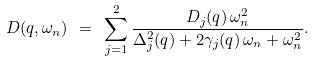Convert formula to latex. <formula><loc_0><loc_0><loc_500><loc_500>D ( q , \omega _ { n } ) \ = \ \sum _ { j = 1 } ^ { 2 } \frac { D _ { j } ( q ) \, \omega _ { n } ^ { 2 } } { \Delta _ { j } ^ { 2 } ( q ) + 2 \gamma _ { j } ( q ) \, \omega _ { n } + \omega _ { n } ^ { 2 } } .</formula> 